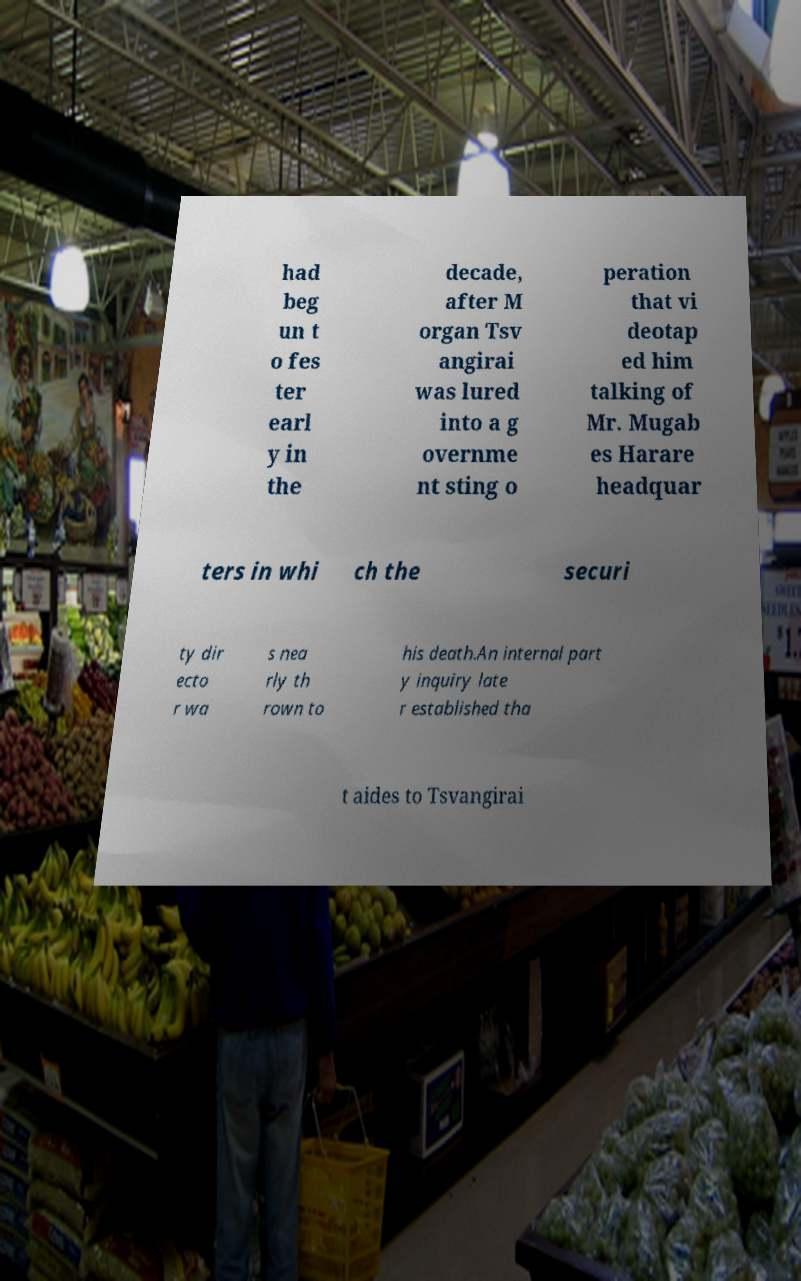Please identify and transcribe the text found in this image. had beg un t o fes ter earl y in the decade, after M organ Tsv angirai was lured into a g overnme nt sting o peration that vi deotap ed him talking of Mr. Mugab es Harare headquar ters in whi ch the securi ty dir ecto r wa s nea rly th rown to his death.An internal part y inquiry late r established tha t aides to Tsvangirai 